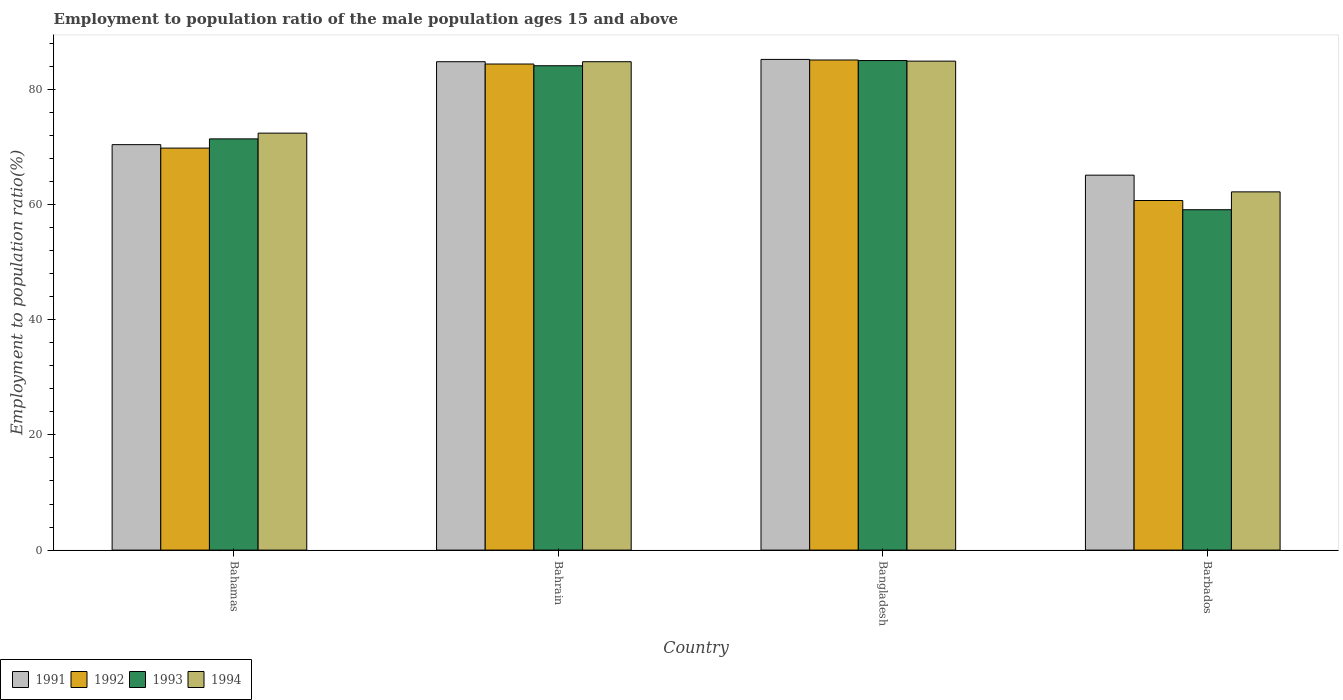How many different coloured bars are there?
Provide a short and direct response. 4. How many groups of bars are there?
Give a very brief answer. 4. Are the number of bars per tick equal to the number of legend labels?
Provide a succinct answer. Yes. Are the number of bars on each tick of the X-axis equal?
Your answer should be compact. Yes. How many bars are there on the 2nd tick from the left?
Provide a succinct answer. 4. What is the label of the 2nd group of bars from the left?
Provide a succinct answer. Bahrain. In how many cases, is the number of bars for a given country not equal to the number of legend labels?
Your answer should be very brief. 0. What is the employment to population ratio in 1991 in Bahamas?
Your response must be concise. 70.4. Across all countries, what is the maximum employment to population ratio in 1992?
Offer a very short reply. 85.1. Across all countries, what is the minimum employment to population ratio in 1994?
Ensure brevity in your answer.  62.2. In which country was the employment to population ratio in 1994 minimum?
Ensure brevity in your answer.  Barbados. What is the total employment to population ratio in 1992 in the graph?
Your answer should be compact. 300. What is the difference between the employment to population ratio in 1993 in Bangladesh and that in Barbados?
Offer a very short reply. 25.9. What is the difference between the employment to population ratio in 1993 in Barbados and the employment to population ratio in 1994 in Bahrain?
Offer a very short reply. -25.7. What is the average employment to population ratio in 1993 per country?
Your response must be concise. 74.9. What is the difference between the employment to population ratio of/in 1991 and employment to population ratio of/in 1993 in Barbados?
Provide a succinct answer. 6. In how many countries, is the employment to population ratio in 1994 greater than 56 %?
Offer a very short reply. 4. What is the ratio of the employment to population ratio in 1993 in Bahamas to that in Barbados?
Your answer should be very brief. 1.21. What is the difference between the highest and the second highest employment to population ratio in 1992?
Offer a terse response. -14.6. What is the difference between the highest and the lowest employment to population ratio in 1992?
Provide a succinct answer. 24.4. In how many countries, is the employment to population ratio in 1992 greater than the average employment to population ratio in 1992 taken over all countries?
Your answer should be compact. 2. Is the sum of the employment to population ratio in 1994 in Bangladesh and Barbados greater than the maximum employment to population ratio in 1992 across all countries?
Give a very brief answer. Yes. Is it the case that in every country, the sum of the employment to population ratio in 1991 and employment to population ratio in 1994 is greater than the employment to population ratio in 1993?
Ensure brevity in your answer.  Yes. How many bars are there?
Your answer should be compact. 16. Does the graph contain any zero values?
Make the answer very short. No. Does the graph contain grids?
Keep it short and to the point. No. How are the legend labels stacked?
Offer a terse response. Horizontal. What is the title of the graph?
Keep it short and to the point. Employment to population ratio of the male population ages 15 and above. What is the label or title of the Y-axis?
Provide a succinct answer. Employment to population ratio(%). What is the Employment to population ratio(%) in 1991 in Bahamas?
Keep it short and to the point. 70.4. What is the Employment to population ratio(%) of 1992 in Bahamas?
Provide a short and direct response. 69.8. What is the Employment to population ratio(%) in 1993 in Bahamas?
Make the answer very short. 71.4. What is the Employment to population ratio(%) of 1994 in Bahamas?
Give a very brief answer. 72.4. What is the Employment to population ratio(%) in 1991 in Bahrain?
Offer a terse response. 84.8. What is the Employment to population ratio(%) of 1992 in Bahrain?
Your answer should be very brief. 84.4. What is the Employment to population ratio(%) of 1993 in Bahrain?
Your answer should be compact. 84.1. What is the Employment to population ratio(%) in 1994 in Bahrain?
Your answer should be very brief. 84.8. What is the Employment to population ratio(%) of 1991 in Bangladesh?
Your response must be concise. 85.2. What is the Employment to population ratio(%) in 1992 in Bangladesh?
Keep it short and to the point. 85.1. What is the Employment to population ratio(%) in 1993 in Bangladesh?
Your response must be concise. 85. What is the Employment to population ratio(%) in 1994 in Bangladesh?
Ensure brevity in your answer.  84.9. What is the Employment to population ratio(%) in 1991 in Barbados?
Keep it short and to the point. 65.1. What is the Employment to population ratio(%) in 1992 in Barbados?
Your response must be concise. 60.7. What is the Employment to population ratio(%) in 1993 in Barbados?
Offer a terse response. 59.1. What is the Employment to population ratio(%) of 1994 in Barbados?
Your answer should be very brief. 62.2. Across all countries, what is the maximum Employment to population ratio(%) in 1991?
Provide a short and direct response. 85.2. Across all countries, what is the maximum Employment to population ratio(%) in 1992?
Give a very brief answer. 85.1. Across all countries, what is the maximum Employment to population ratio(%) in 1993?
Offer a terse response. 85. Across all countries, what is the maximum Employment to population ratio(%) of 1994?
Offer a very short reply. 84.9. Across all countries, what is the minimum Employment to population ratio(%) of 1991?
Provide a short and direct response. 65.1. Across all countries, what is the minimum Employment to population ratio(%) in 1992?
Your answer should be very brief. 60.7. Across all countries, what is the minimum Employment to population ratio(%) in 1993?
Your response must be concise. 59.1. Across all countries, what is the minimum Employment to population ratio(%) of 1994?
Provide a short and direct response. 62.2. What is the total Employment to population ratio(%) in 1991 in the graph?
Offer a very short reply. 305.5. What is the total Employment to population ratio(%) of 1992 in the graph?
Offer a terse response. 300. What is the total Employment to population ratio(%) in 1993 in the graph?
Make the answer very short. 299.6. What is the total Employment to population ratio(%) in 1994 in the graph?
Keep it short and to the point. 304.3. What is the difference between the Employment to population ratio(%) in 1991 in Bahamas and that in Bahrain?
Your answer should be very brief. -14.4. What is the difference between the Employment to population ratio(%) in 1992 in Bahamas and that in Bahrain?
Give a very brief answer. -14.6. What is the difference between the Employment to population ratio(%) of 1994 in Bahamas and that in Bahrain?
Offer a very short reply. -12.4. What is the difference between the Employment to population ratio(%) of 1991 in Bahamas and that in Bangladesh?
Your response must be concise. -14.8. What is the difference between the Employment to population ratio(%) of 1992 in Bahamas and that in Bangladesh?
Offer a terse response. -15.3. What is the difference between the Employment to population ratio(%) in 1993 in Bahamas and that in Bangladesh?
Your answer should be very brief. -13.6. What is the difference between the Employment to population ratio(%) of 1993 in Bahamas and that in Barbados?
Your answer should be very brief. 12.3. What is the difference between the Employment to population ratio(%) of 1991 in Bahrain and that in Bangladesh?
Offer a terse response. -0.4. What is the difference between the Employment to population ratio(%) of 1993 in Bahrain and that in Bangladesh?
Your response must be concise. -0.9. What is the difference between the Employment to population ratio(%) in 1992 in Bahrain and that in Barbados?
Ensure brevity in your answer.  23.7. What is the difference between the Employment to population ratio(%) in 1993 in Bahrain and that in Barbados?
Your response must be concise. 25. What is the difference between the Employment to population ratio(%) in 1994 in Bahrain and that in Barbados?
Your answer should be compact. 22.6. What is the difference between the Employment to population ratio(%) of 1991 in Bangladesh and that in Barbados?
Your response must be concise. 20.1. What is the difference between the Employment to population ratio(%) of 1992 in Bangladesh and that in Barbados?
Offer a terse response. 24.4. What is the difference between the Employment to population ratio(%) in 1993 in Bangladesh and that in Barbados?
Offer a terse response. 25.9. What is the difference between the Employment to population ratio(%) of 1994 in Bangladesh and that in Barbados?
Ensure brevity in your answer.  22.7. What is the difference between the Employment to population ratio(%) of 1991 in Bahamas and the Employment to population ratio(%) of 1992 in Bahrain?
Your answer should be compact. -14. What is the difference between the Employment to population ratio(%) of 1991 in Bahamas and the Employment to population ratio(%) of 1993 in Bahrain?
Offer a very short reply. -13.7. What is the difference between the Employment to population ratio(%) of 1991 in Bahamas and the Employment to population ratio(%) of 1994 in Bahrain?
Your answer should be very brief. -14.4. What is the difference between the Employment to population ratio(%) of 1992 in Bahamas and the Employment to population ratio(%) of 1993 in Bahrain?
Your answer should be compact. -14.3. What is the difference between the Employment to population ratio(%) of 1993 in Bahamas and the Employment to population ratio(%) of 1994 in Bahrain?
Keep it short and to the point. -13.4. What is the difference between the Employment to population ratio(%) in 1991 in Bahamas and the Employment to population ratio(%) in 1992 in Bangladesh?
Your response must be concise. -14.7. What is the difference between the Employment to population ratio(%) in 1991 in Bahamas and the Employment to population ratio(%) in 1993 in Bangladesh?
Keep it short and to the point. -14.6. What is the difference between the Employment to population ratio(%) of 1991 in Bahamas and the Employment to population ratio(%) of 1994 in Bangladesh?
Ensure brevity in your answer.  -14.5. What is the difference between the Employment to population ratio(%) of 1992 in Bahamas and the Employment to population ratio(%) of 1993 in Bangladesh?
Your response must be concise. -15.2. What is the difference between the Employment to population ratio(%) in 1992 in Bahamas and the Employment to population ratio(%) in 1994 in Bangladesh?
Give a very brief answer. -15.1. What is the difference between the Employment to population ratio(%) of 1991 in Bahamas and the Employment to population ratio(%) of 1992 in Barbados?
Your answer should be very brief. 9.7. What is the difference between the Employment to population ratio(%) in 1992 in Bahamas and the Employment to population ratio(%) in 1993 in Barbados?
Make the answer very short. 10.7. What is the difference between the Employment to population ratio(%) of 1993 in Bahamas and the Employment to population ratio(%) of 1994 in Barbados?
Make the answer very short. 9.2. What is the difference between the Employment to population ratio(%) of 1991 in Bahrain and the Employment to population ratio(%) of 1992 in Bangladesh?
Provide a succinct answer. -0.3. What is the difference between the Employment to population ratio(%) in 1992 in Bahrain and the Employment to population ratio(%) in 1994 in Bangladesh?
Make the answer very short. -0.5. What is the difference between the Employment to population ratio(%) in 1991 in Bahrain and the Employment to population ratio(%) in 1992 in Barbados?
Provide a succinct answer. 24.1. What is the difference between the Employment to population ratio(%) of 1991 in Bahrain and the Employment to population ratio(%) of 1993 in Barbados?
Provide a succinct answer. 25.7. What is the difference between the Employment to population ratio(%) in 1991 in Bahrain and the Employment to population ratio(%) in 1994 in Barbados?
Your answer should be very brief. 22.6. What is the difference between the Employment to population ratio(%) in 1992 in Bahrain and the Employment to population ratio(%) in 1993 in Barbados?
Make the answer very short. 25.3. What is the difference between the Employment to population ratio(%) of 1993 in Bahrain and the Employment to population ratio(%) of 1994 in Barbados?
Provide a short and direct response. 21.9. What is the difference between the Employment to population ratio(%) of 1991 in Bangladesh and the Employment to population ratio(%) of 1993 in Barbados?
Your response must be concise. 26.1. What is the difference between the Employment to population ratio(%) of 1991 in Bangladesh and the Employment to population ratio(%) of 1994 in Barbados?
Offer a very short reply. 23. What is the difference between the Employment to population ratio(%) in 1992 in Bangladesh and the Employment to population ratio(%) in 1993 in Barbados?
Provide a short and direct response. 26. What is the difference between the Employment to population ratio(%) of 1992 in Bangladesh and the Employment to population ratio(%) of 1994 in Barbados?
Make the answer very short. 22.9. What is the difference between the Employment to population ratio(%) in 1993 in Bangladesh and the Employment to population ratio(%) in 1994 in Barbados?
Keep it short and to the point. 22.8. What is the average Employment to population ratio(%) in 1991 per country?
Offer a very short reply. 76.38. What is the average Employment to population ratio(%) in 1992 per country?
Your answer should be compact. 75. What is the average Employment to population ratio(%) in 1993 per country?
Your answer should be compact. 74.9. What is the average Employment to population ratio(%) in 1994 per country?
Offer a very short reply. 76.08. What is the difference between the Employment to population ratio(%) of 1991 and Employment to population ratio(%) of 1992 in Bahamas?
Give a very brief answer. 0.6. What is the difference between the Employment to population ratio(%) of 1992 and Employment to population ratio(%) of 1994 in Bahamas?
Your answer should be very brief. -2.6. What is the difference between the Employment to population ratio(%) in 1993 and Employment to population ratio(%) in 1994 in Bahamas?
Provide a short and direct response. -1. What is the difference between the Employment to population ratio(%) in 1991 and Employment to population ratio(%) in 1992 in Bahrain?
Provide a succinct answer. 0.4. What is the difference between the Employment to population ratio(%) of 1991 and Employment to population ratio(%) of 1993 in Bahrain?
Your response must be concise. 0.7. What is the difference between the Employment to population ratio(%) of 1991 and Employment to population ratio(%) of 1994 in Bahrain?
Provide a succinct answer. 0. What is the difference between the Employment to population ratio(%) in 1993 and Employment to population ratio(%) in 1994 in Bahrain?
Offer a terse response. -0.7. What is the difference between the Employment to population ratio(%) in 1991 and Employment to population ratio(%) in 1992 in Bangladesh?
Your response must be concise. 0.1. What is the difference between the Employment to population ratio(%) of 1991 and Employment to population ratio(%) of 1994 in Bangladesh?
Offer a terse response. 0.3. What is the difference between the Employment to population ratio(%) of 1993 and Employment to population ratio(%) of 1994 in Bangladesh?
Make the answer very short. 0.1. What is the difference between the Employment to population ratio(%) of 1991 and Employment to population ratio(%) of 1993 in Barbados?
Provide a short and direct response. 6. What is the difference between the Employment to population ratio(%) of 1991 and Employment to population ratio(%) of 1994 in Barbados?
Ensure brevity in your answer.  2.9. What is the ratio of the Employment to population ratio(%) of 1991 in Bahamas to that in Bahrain?
Your response must be concise. 0.83. What is the ratio of the Employment to population ratio(%) of 1992 in Bahamas to that in Bahrain?
Make the answer very short. 0.83. What is the ratio of the Employment to population ratio(%) in 1993 in Bahamas to that in Bahrain?
Keep it short and to the point. 0.85. What is the ratio of the Employment to population ratio(%) in 1994 in Bahamas to that in Bahrain?
Your answer should be compact. 0.85. What is the ratio of the Employment to population ratio(%) in 1991 in Bahamas to that in Bangladesh?
Keep it short and to the point. 0.83. What is the ratio of the Employment to population ratio(%) in 1992 in Bahamas to that in Bangladesh?
Give a very brief answer. 0.82. What is the ratio of the Employment to population ratio(%) in 1993 in Bahamas to that in Bangladesh?
Keep it short and to the point. 0.84. What is the ratio of the Employment to population ratio(%) of 1994 in Bahamas to that in Bangladesh?
Keep it short and to the point. 0.85. What is the ratio of the Employment to population ratio(%) in 1991 in Bahamas to that in Barbados?
Give a very brief answer. 1.08. What is the ratio of the Employment to population ratio(%) of 1992 in Bahamas to that in Barbados?
Offer a terse response. 1.15. What is the ratio of the Employment to population ratio(%) of 1993 in Bahamas to that in Barbados?
Provide a short and direct response. 1.21. What is the ratio of the Employment to population ratio(%) in 1994 in Bahamas to that in Barbados?
Make the answer very short. 1.16. What is the ratio of the Employment to population ratio(%) in 1992 in Bahrain to that in Bangladesh?
Give a very brief answer. 0.99. What is the ratio of the Employment to population ratio(%) of 1994 in Bahrain to that in Bangladesh?
Offer a terse response. 1. What is the ratio of the Employment to population ratio(%) in 1991 in Bahrain to that in Barbados?
Give a very brief answer. 1.3. What is the ratio of the Employment to population ratio(%) in 1992 in Bahrain to that in Barbados?
Offer a very short reply. 1.39. What is the ratio of the Employment to population ratio(%) in 1993 in Bahrain to that in Barbados?
Offer a very short reply. 1.42. What is the ratio of the Employment to population ratio(%) of 1994 in Bahrain to that in Barbados?
Offer a terse response. 1.36. What is the ratio of the Employment to population ratio(%) of 1991 in Bangladesh to that in Barbados?
Ensure brevity in your answer.  1.31. What is the ratio of the Employment to population ratio(%) of 1992 in Bangladesh to that in Barbados?
Offer a very short reply. 1.4. What is the ratio of the Employment to population ratio(%) in 1993 in Bangladesh to that in Barbados?
Ensure brevity in your answer.  1.44. What is the ratio of the Employment to population ratio(%) of 1994 in Bangladesh to that in Barbados?
Ensure brevity in your answer.  1.36. What is the difference between the highest and the second highest Employment to population ratio(%) of 1991?
Your answer should be compact. 0.4. What is the difference between the highest and the second highest Employment to population ratio(%) in 1993?
Offer a very short reply. 0.9. What is the difference between the highest and the second highest Employment to population ratio(%) in 1994?
Your response must be concise. 0.1. What is the difference between the highest and the lowest Employment to population ratio(%) of 1991?
Provide a succinct answer. 20.1. What is the difference between the highest and the lowest Employment to population ratio(%) of 1992?
Your response must be concise. 24.4. What is the difference between the highest and the lowest Employment to population ratio(%) in 1993?
Provide a short and direct response. 25.9. What is the difference between the highest and the lowest Employment to population ratio(%) of 1994?
Offer a terse response. 22.7. 